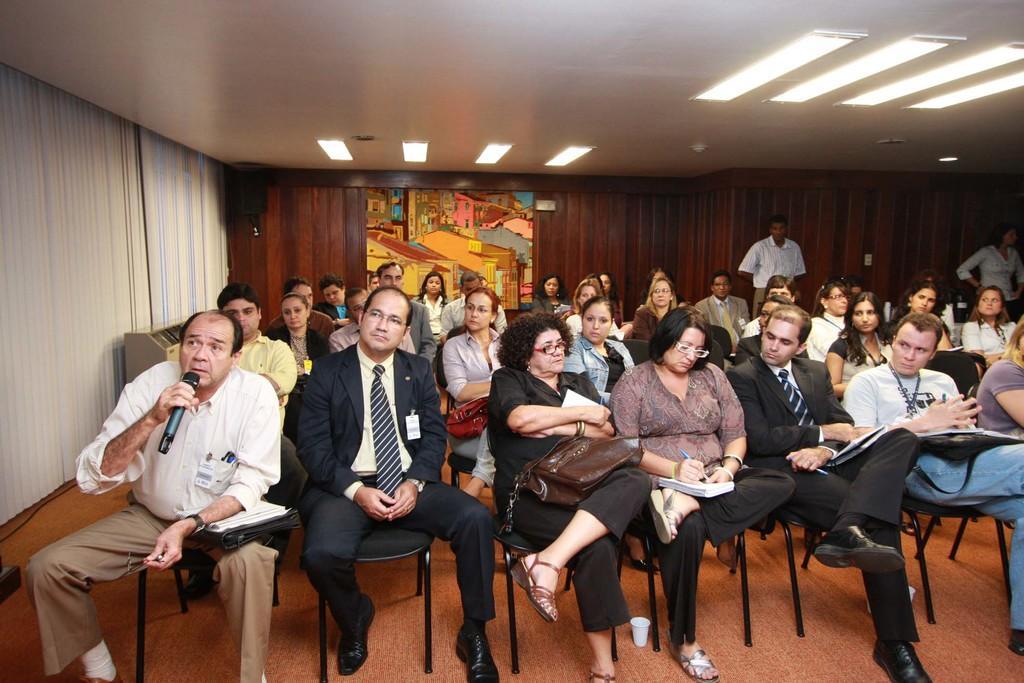Please provide a concise description of this image. This image is clicked inside a room. There are many people sitting on the chairs. They are holding books and pens in the hand. To the left there is a man holding a microphone in his hand. In the background there is a wooden wall. There is a frame on the wall. There are lights to the ceiling. To the extreme left there are window blinds to the wall. 